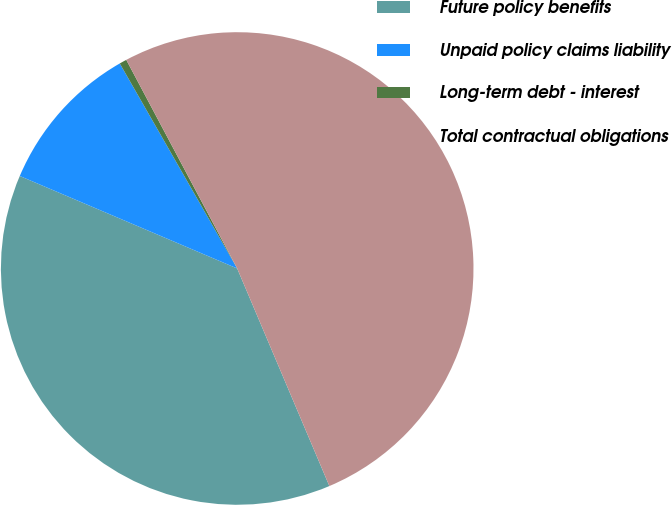Convert chart. <chart><loc_0><loc_0><loc_500><loc_500><pie_chart><fcel>Future policy benefits<fcel>Unpaid policy claims liability<fcel>Long-term debt - interest<fcel>Total contractual obligations<nl><fcel>37.78%<fcel>10.32%<fcel>0.5%<fcel>51.4%<nl></chart> 